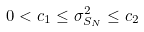Convert formula to latex. <formula><loc_0><loc_0><loc_500><loc_500>0 < c _ { 1 } \leq \sigma _ { S _ { N } } ^ { 2 } \leq c _ { 2 }</formula> 